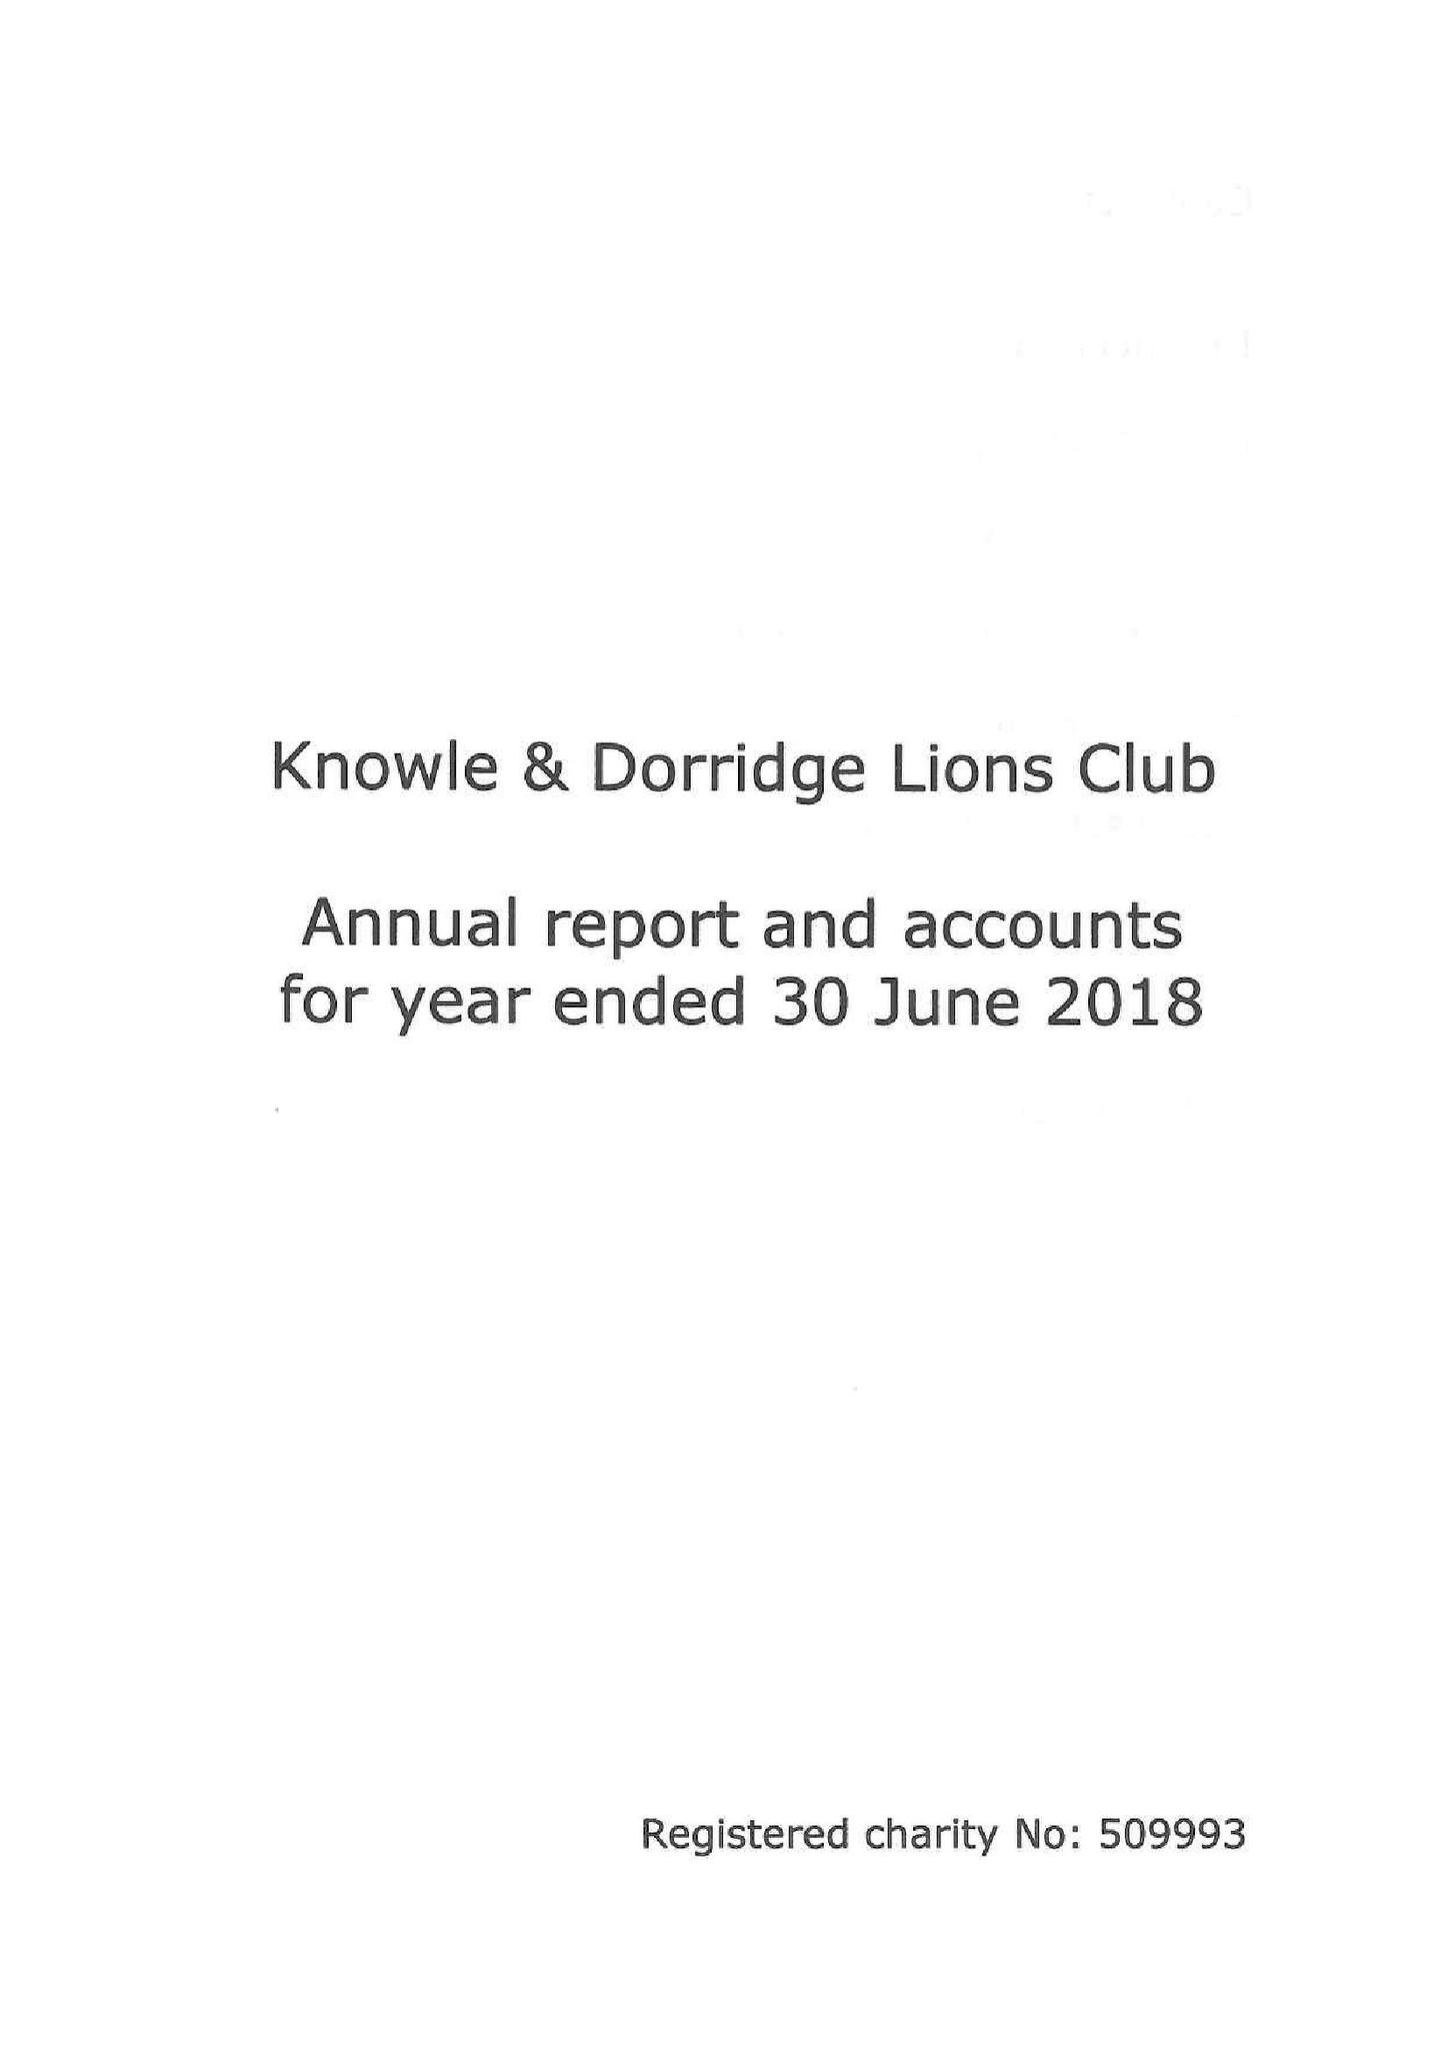What is the value for the address__postcode?
Answer the question using a single word or phrase. B93 9ET 